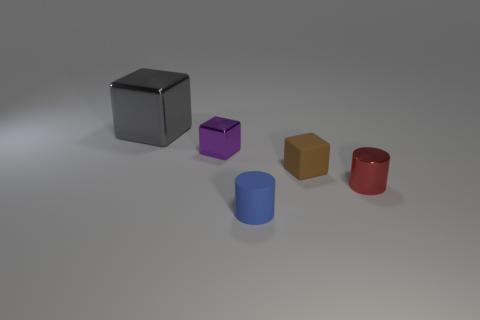Add 1 cyan matte blocks. How many objects exist? 6 Subtract 0 cyan cylinders. How many objects are left? 5 Subtract all cylinders. How many objects are left? 3 Subtract all yellow metallic cylinders. Subtract all rubber cylinders. How many objects are left? 4 Add 3 tiny red cylinders. How many tiny red cylinders are left? 4 Add 5 small blocks. How many small blocks exist? 7 